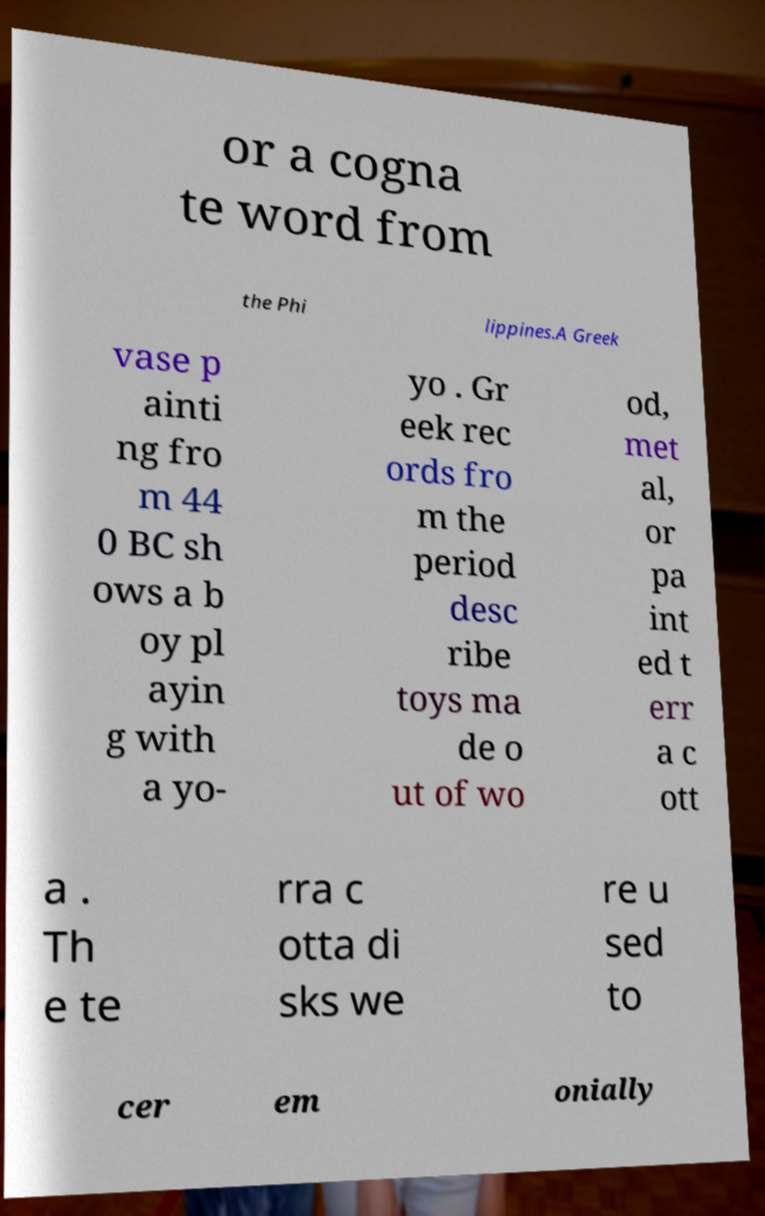For documentation purposes, I need the text within this image transcribed. Could you provide that? or a cogna te word from the Phi lippines.A Greek vase p ainti ng fro m 44 0 BC sh ows a b oy pl ayin g with a yo- yo . Gr eek rec ords fro m the period desc ribe toys ma de o ut of wo od, met al, or pa int ed t err a c ott a . Th e te rra c otta di sks we re u sed to cer em onially 